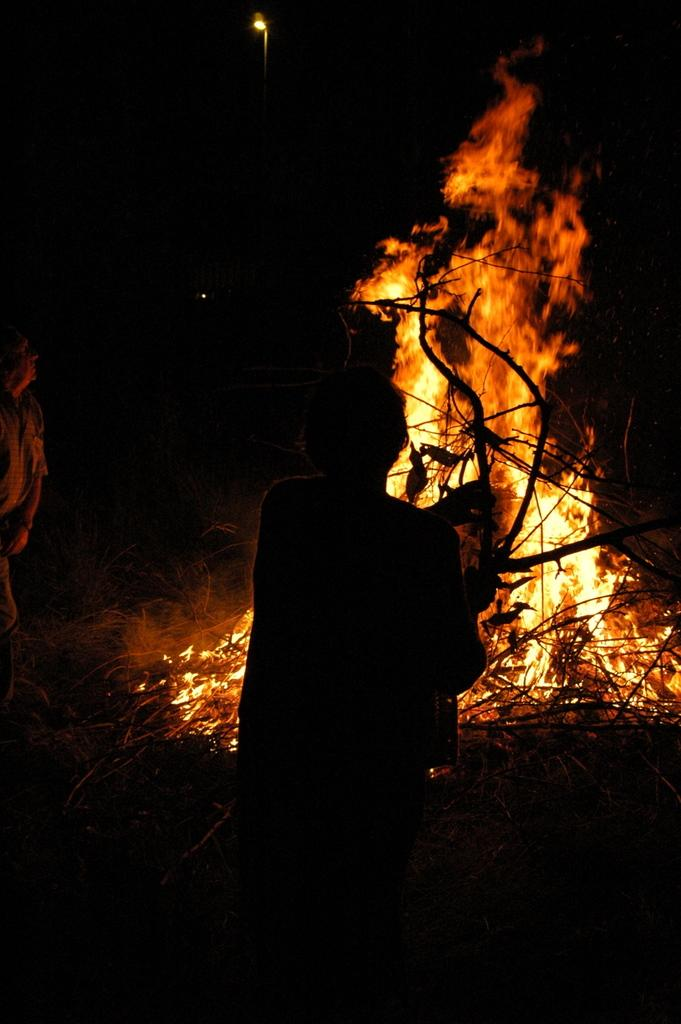How many people are in the image? There are two people in the image. What is the position of the people in the image? The people are on the ground. What can be seen in the image besides the people? There are branches of a tree, fire, and a light in the image. What type of cork can be seen in the image? There is no cork present in the image. Can you compare the size of the fire to the size of the people in the image? The provided facts do not include information about the size of the fire or the people, so it is not possible to make a comparison. 